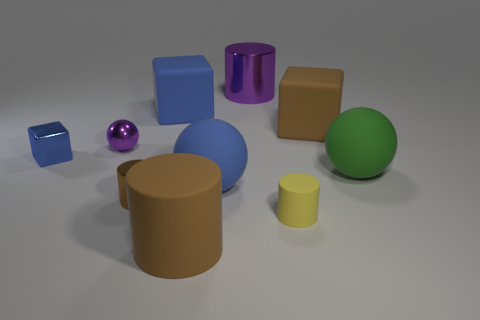There is another block that is the same color as the small metallic block; what material is it?
Ensure brevity in your answer.  Rubber. What number of other objects are the same color as the tiny matte object?
Your response must be concise. 0. What shape is the large brown thing in front of the small blue object?
Your response must be concise. Cylinder. What number of things are gray cubes or large rubber spheres?
Keep it short and to the point. 2. There is a yellow thing; is it the same size as the cylinder on the left side of the large blue matte cube?
Provide a short and direct response. Yes. What number of other things are there of the same material as the blue ball
Offer a terse response. 5. How many things are brown cylinders behind the brown matte cylinder or big cylinders that are in front of the yellow object?
Your response must be concise. 2. There is a purple thing that is the same shape as the yellow thing; what is it made of?
Keep it short and to the point. Metal. Are there any tiny cyan things?
Keep it short and to the point. No. There is a blue thing that is both behind the green matte ball and in front of the brown rubber cube; what is its size?
Give a very brief answer. Small. 